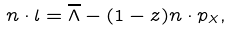<formula> <loc_0><loc_0><loc_500><loc_500>n \cdot l = \overline { \Lambda } - ( 1 - z ) n \cdot p _ { X } ,</formula> 